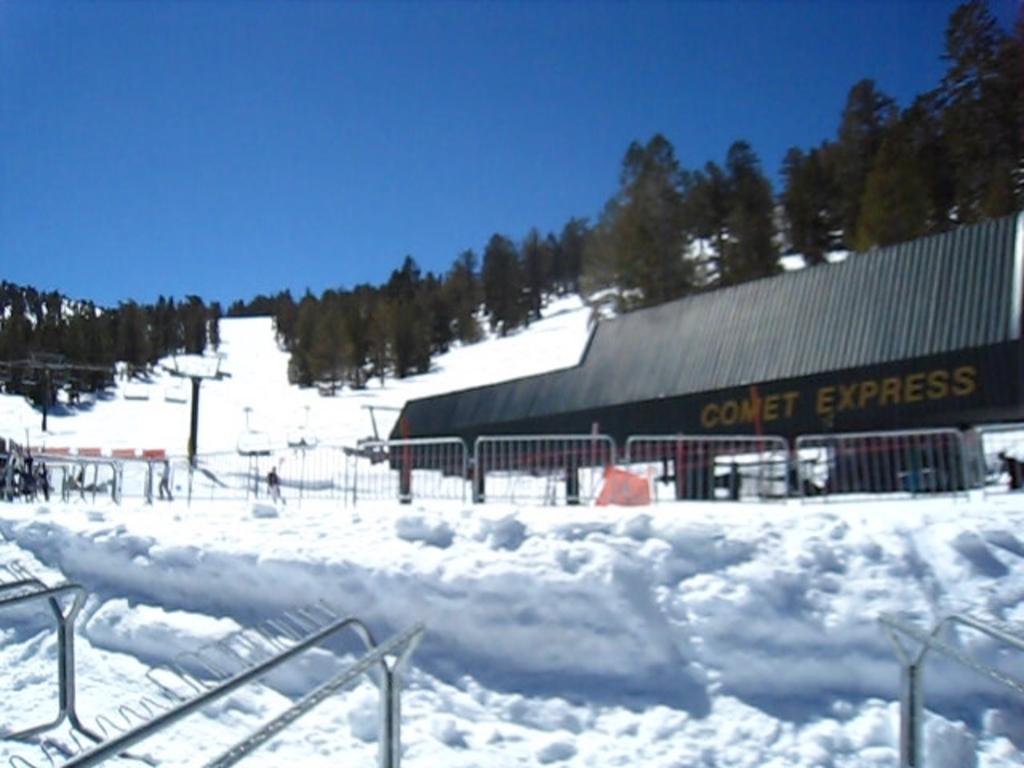Describe this image in one or two sentences. In this picture I can see the snow in front and in the middle of this picture I see the railings, few people, poles and a building and I see something is written on it. In the background I see number of trees and the sky. 